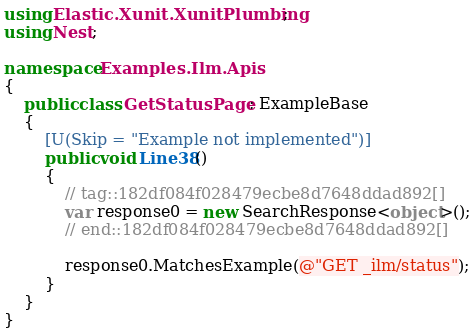Convert code to text. <code><loc_0><loc_0><loc_500><loc_500><_C#_>using Elastic.Xunit.XunitPlumbing;
using Nest;

namespace Examples.Ilm.Apis
{
	public class GetStatusPage : ExampleBase
	{
		[U(Skip = "Example not implemented")]
		public void Line38()
		{
			// tag::182df084f028479ecbe8d7648ddad892[]
			var response0 = new SearchResponse<object>();
			// end::182df084f028479ecbe8d7648ddad892[]

			response0.MatchesExample(@"GET _ilm/status");
		}
	}
}</code> 